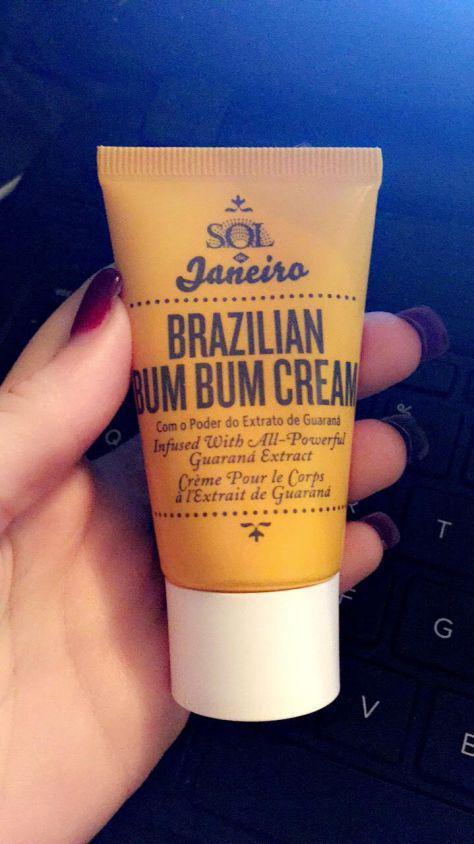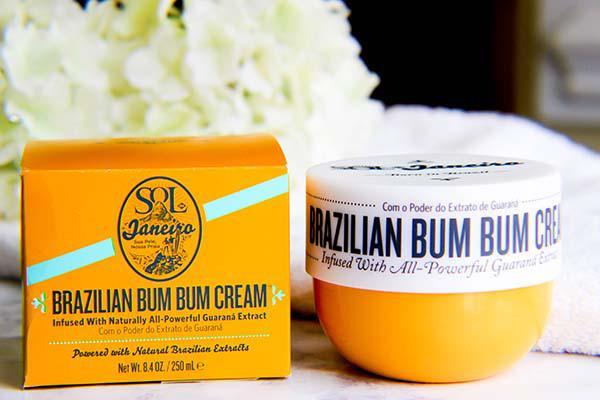The first image is the image on the left, the second image is the image on the right. Evaluate the accuracy of this statement regarding the images: "One of the images contains only a single orange squeeze tube with a white cap.". Is it true? Answer yes or no. Yes. The first image is the image on the left, the second image is the image on the right. Analyze the images presented: Is the assertion "The left image contains one yellow tube with a flat white cap, and the right image includes a product with a yellow bowl-shaped bottom and a flat-topped white lid with black print around it." valid? Answer yes or no. Yes. 